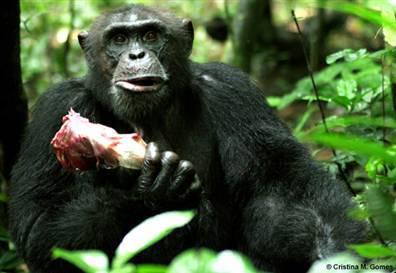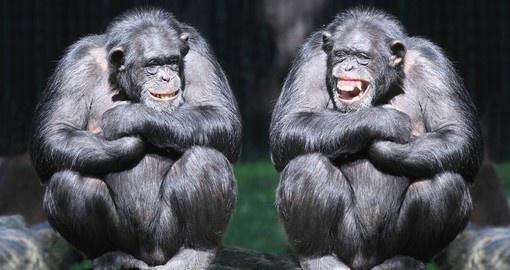The first image is the image on the left, the second image is the image on the right. Analyze the images presented: Is the assertion "Each image contains a pair of chimps posed near each other, and no chimps are young babies." valid? Answer yes or no. No. The first image is the image on the left, the second image is the image on the right. Examine the images to the left and right. Is the description "There are four monkeys." accurate? Answer yes or no. No. 